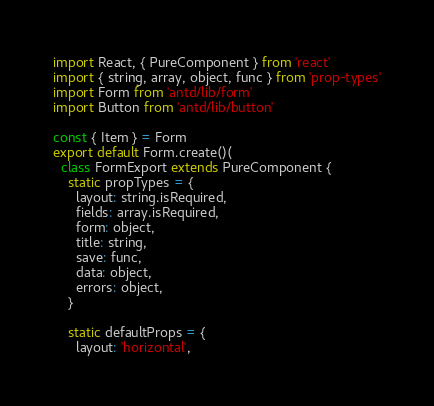<code> <loc_0><loc_0><loc_500><loc_500><_JavaScript_>import React, { PureComponent } from 'react'
import { string, array, object, func } from 'prop-types'
import Form from 'antd/lib/form'
import Button from 'antd/lib/button'

const { Item } = Form
export default Form.create()(
  class FormExport extends PureComponent {
    static propTypes = {
      layout: string.isRequired,
      fields: array.isRequired,
      form: object,
      title: string,
      save: func,
      data: object,
      errors: object,
    }

    static defaultProps = {
      layout: 'horizontal',</code> 